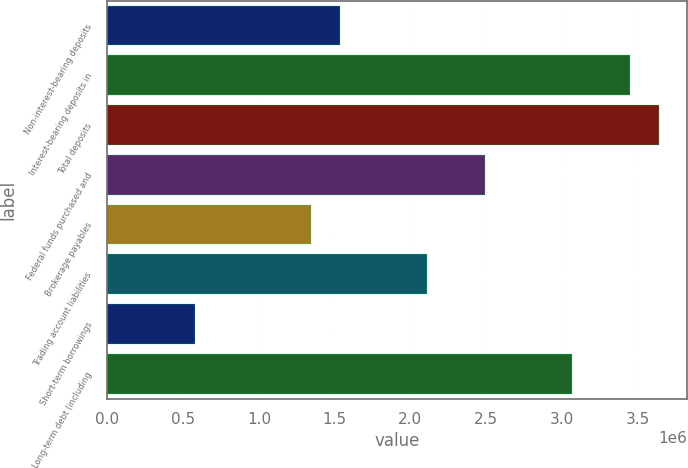Convert chart to OTSL. <chart><loc_0><loc_0><loc_500><loc_500><bar_chart><fcel>Non-interest-bearing deposits<fcel>Interest-bearing deposits in<fcel>Total deposits<fcel>Federal funds purchased and<fcel>Brokerage payables<fcel>Trading account liabilities<fcel>Short-term borrowings<fcel>Long-term debt (including<nl><fcel>1.53391e+06<fcel>3.45126e+06<fcel>3.643e+06<fcel>2.49259e+06<fcel>1.34218e+06<fcel>2.10912e+06<fcel>575237<fcel>3.06779e+06<nl></chart> 